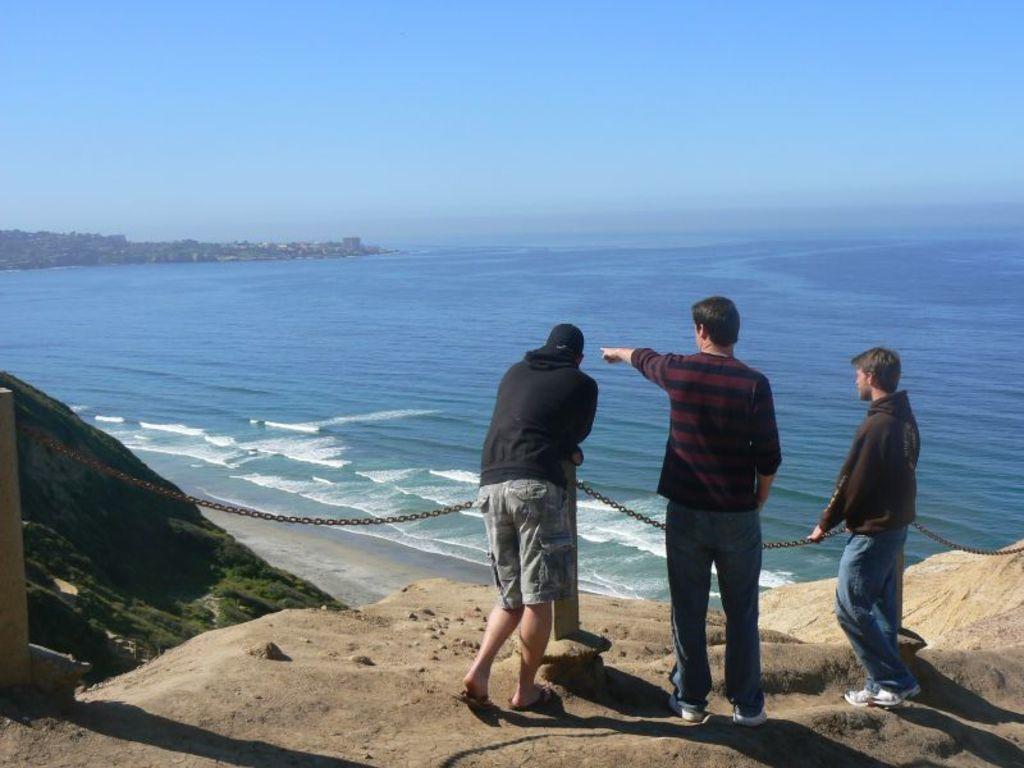In one or two sentences, can you explain what this image depicts? In this picture I see 3 men in front who are standing and I see the chain on the poles in front of them and in the background I see the water and the sky. 